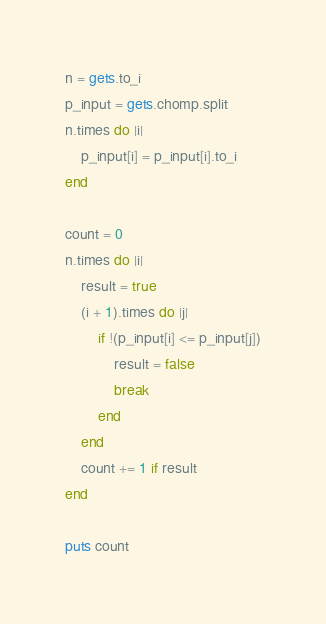<code> <loc_0><loc_0><loc_500><loc_500><_Ruby_>n = gets.to_i
p_input = gets.chomp.split
n.times do |i|
    p_input[i] = p_input[i].to_i
end

count = 0
n.times do |i|
    result = true
    (i + 1).times do |j|
        if !(p_input[i] <= p_input[j])
            result = false
            break
        end
    end
    count += 1 if result
end

puts count</code> 